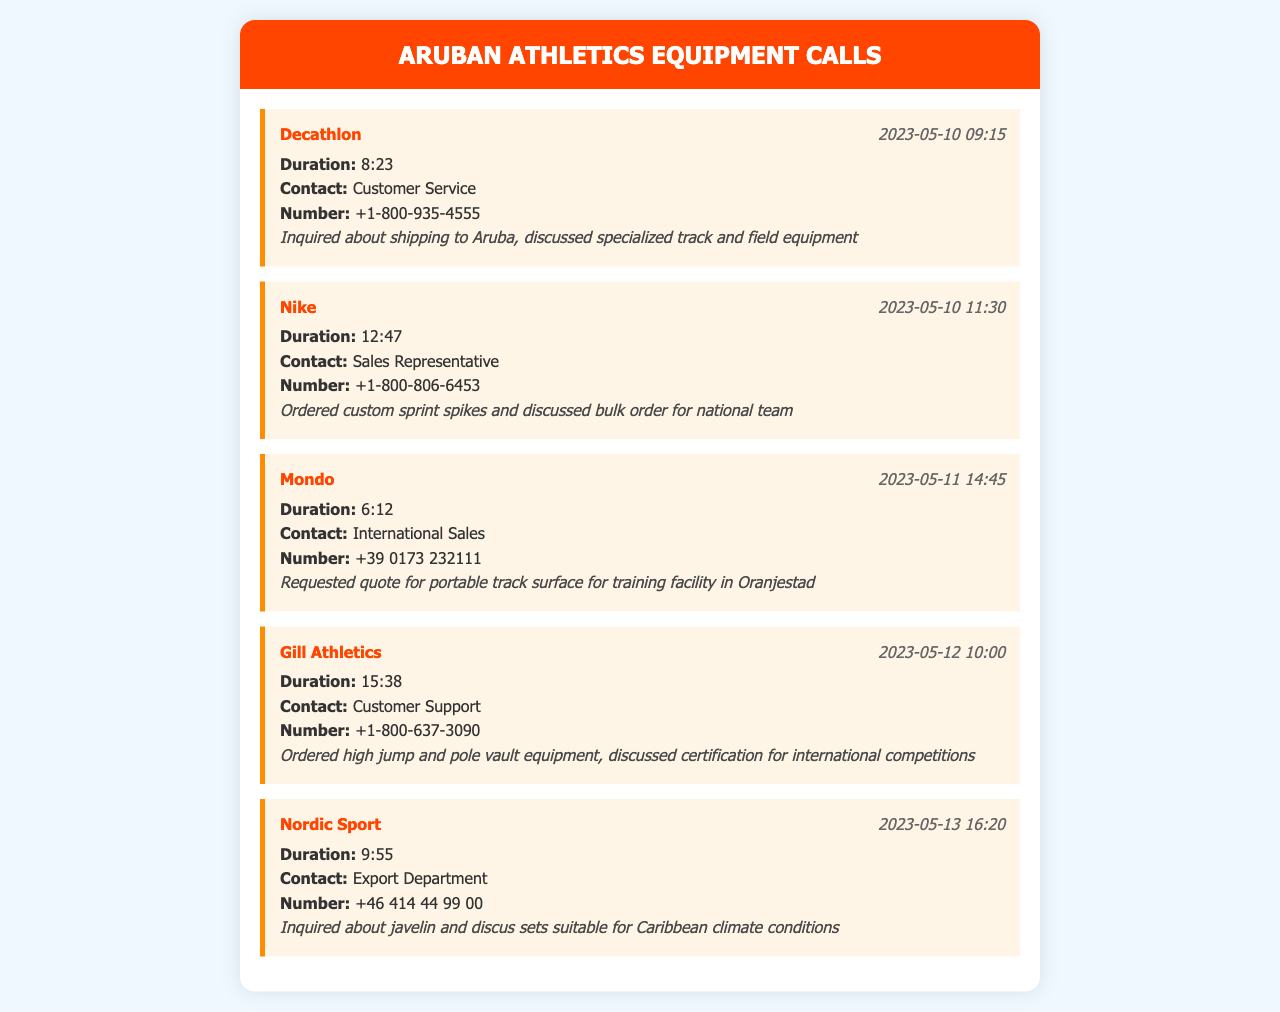What is the duration of the call with Decathlon? The duration of the call is specified directly after the company name in the document.
Answer: 8:23 What type of equipment was ordered from Nike? The type of equipment is mentioned in the call details, which states the specific items discussed.
Answer: Custom sprint spikes Who was contacted at Mondo? The call details provide information about the contact person for each call.
Answer: International Sales What inquiries were made during the call with Nordic Sport? The call notes reveal the main topics discussed in the conversation.
Answer: Javelin and discus sets When was the call to Gill Athletics made? The date and time are noted in the call header of the respective call details.
Answer: 2023-05-12 10:00 What is the contact number for Nike? The contact number is provided in the call details section under each company.
Answer: +1-800-806-6453 How long was the call with Gill Athletics? The duration of the call can be found in the details associated with its respective item.
Answer: 15:38 Which company was contacted for a quote on track surfaces? The company involved is listed along with the contact details for the call.
Answer: Mondo What was discussed regarding certification during the call to Gill Athletics? The notes provide insight into specific topics discussed during the call concerning equipment and competitions.
Answer: Certification for international competitions What is the date of the last call recorded in the document? The date appears prominently in the call header of the last call entry.
Answer: 2023-05-13 